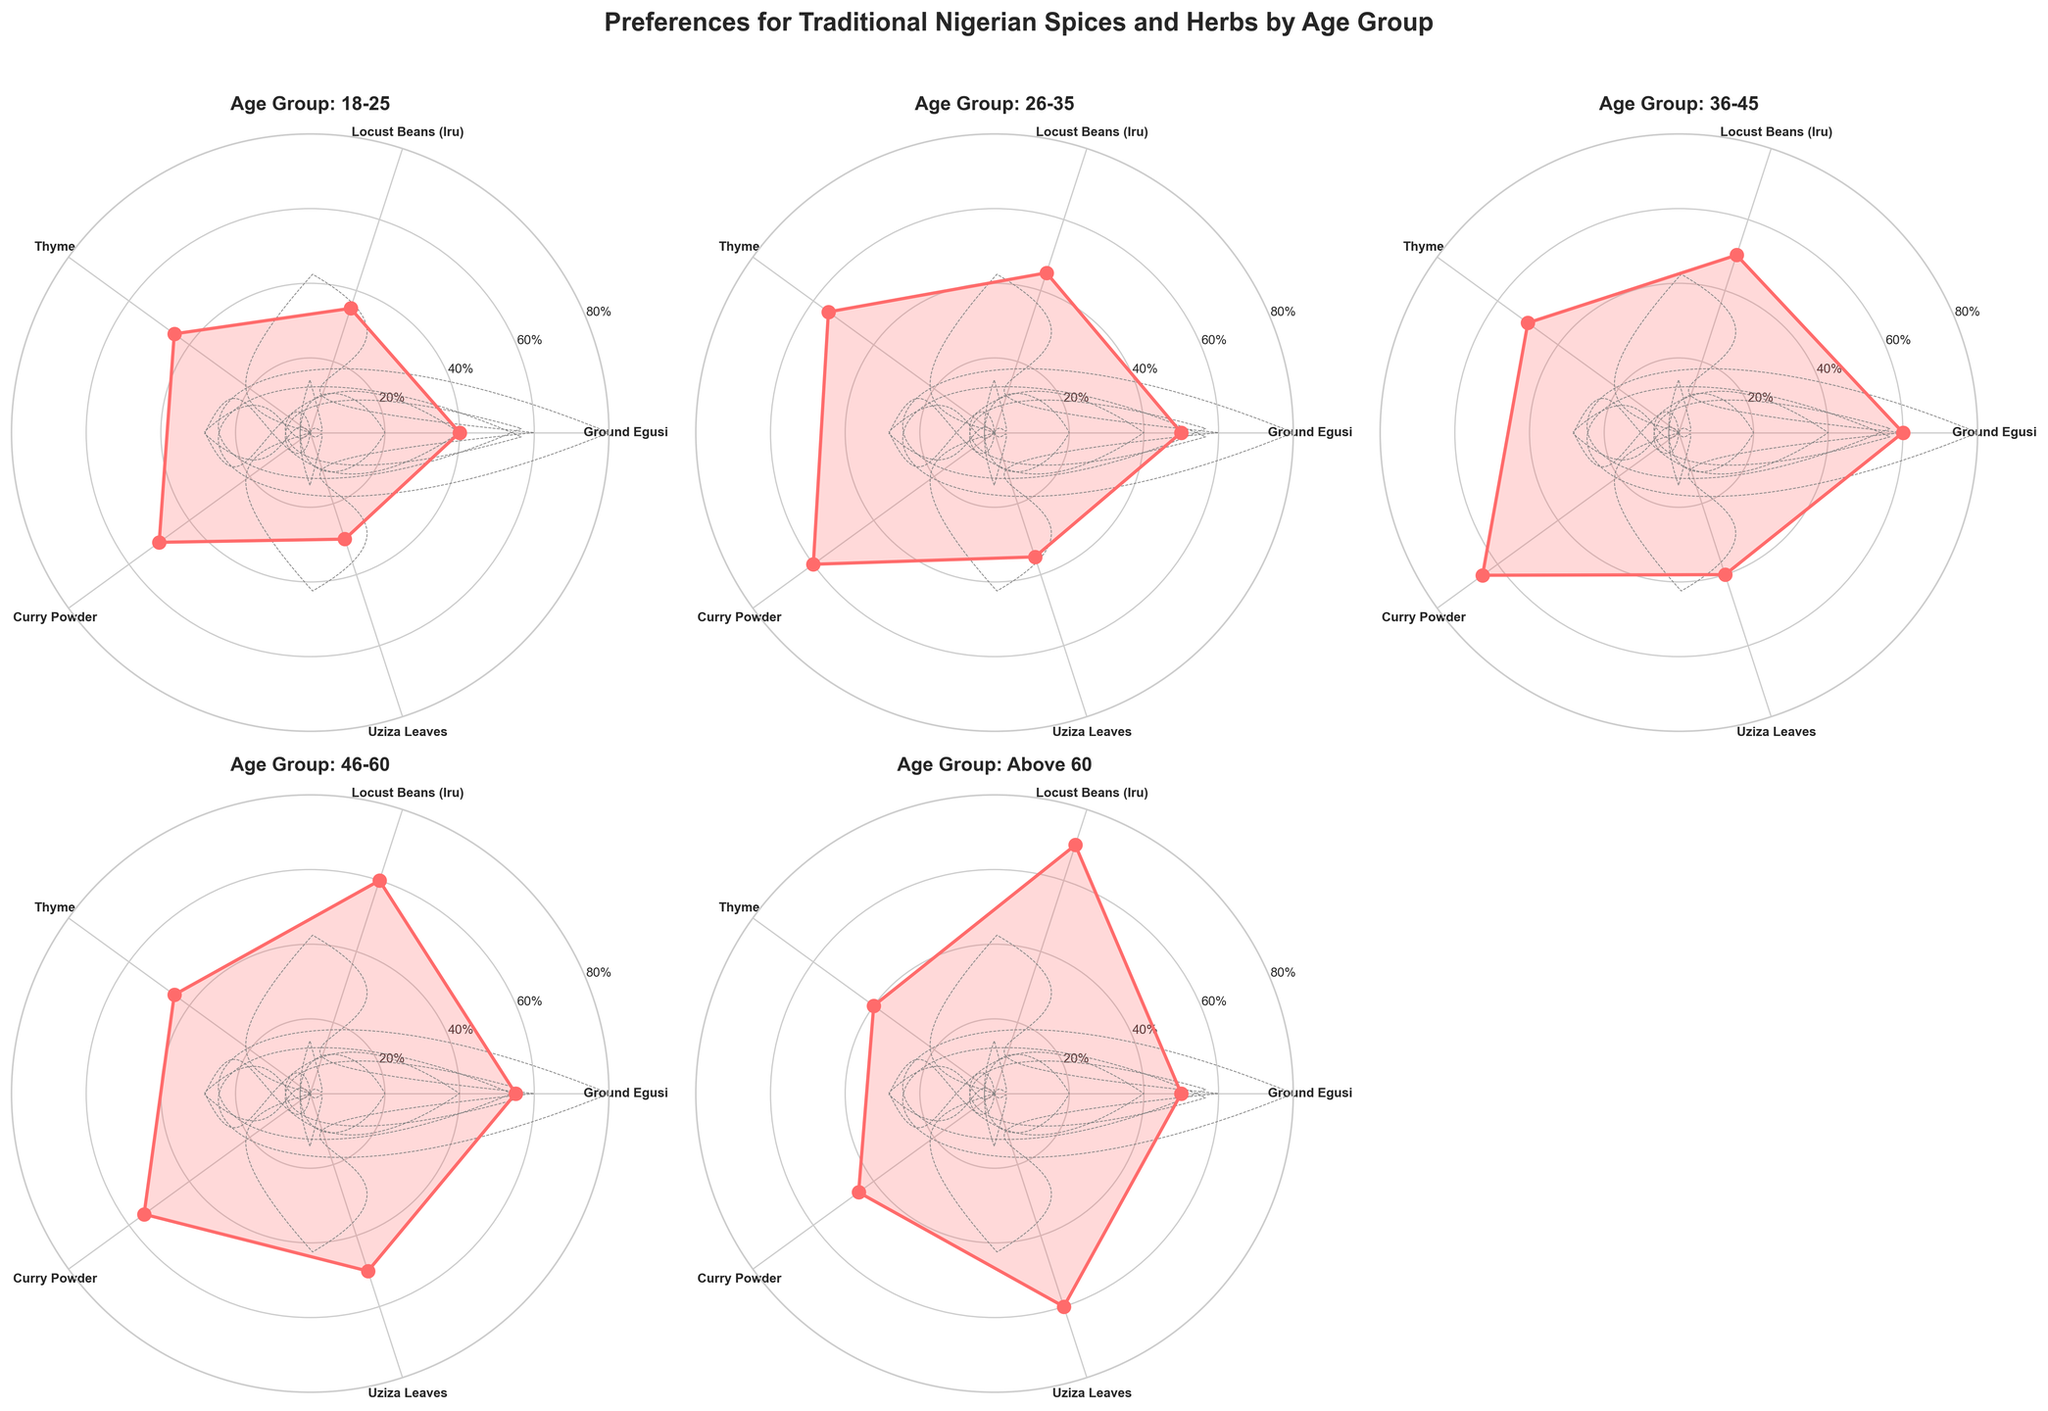How many age groups are represented in the plot? The plot contains individual subplots for each age group. By counting the subplots, we can determine the number of age groups.
Answer: 5 Which spice or herb has the highest preference percentage for the age group 26-35? For the age group 26-35, locate the corresponding subplot and see which spice/herb has the highest value.
Answer: Curry Powder What is the difference in preference percentage for Locust Beans (Iru) between the age groups 18-25 and 26-35? Check the preference percentages for Locust Beans (Iru) in both age groups and subtract the values: 45% (26-35) - 35% (18-25).
Answer: 10% Which age group has the highest preference percentage for Uziza Leaves? Compare the value for Uziza Leaves among all the age groups to see which one is the highest. The highest value is seen in the age group Above 60 with 60%.
Answer: Above 60 Did the preference percentage for Ground Egusi increase or decrease as the age group goes from 18-25 to 36-45? Compare the preference percentages for Ground Egusi in the age groups 18-25 (40%), 26-35 (50%), and 36-45 (60%). The preference percentage is increasing in this age range.
Answer: Increase Which spice or herb shows the least variation in preference percentage across all age groups? Examine the preference percentages for each spice/herb across all age groups. Thyme shows values of 45%, 55%, 50%, 45%, and 40%, showing relatively little variation compared to others. Calculate mean absolute deviation for exact result.
Answer: Thyme What is the average preference percentage for Locust Beans (Iru) across all age groups? Sum the preference values for Locust Beans (Iru) across all age groups: 35 + 45 + 50 + 60 + 70, and then divide by the number of age groups (5). (35+45+50+60+70)/5 = 52%.
Answer: 52% Which age group shows the most balanced preference percentages across all spices and herbs? Find the subplot where the values are more evenly distributed. For example, Age Group 18-25 has percentages 40%, 35%, 45%, 50%, 30%, which shows some balance compared to others.
Answer: 18-25 What is the most common maximum preference percentage among all spice/herb categories? Identify the maximum preference percentage for each spice/herb across all age groups: 60%, 70%, 55%, 65%, 60%, and see which value is more frequent (60% for Ground Egusi and Uziza Leaves).
Answer: 60% Which age group has the lowest preference for Thyme? Compare the preference value of Thyme across all age groups and find the minimum value. The lowest value is for the age group Above 60 with 40%.
Answer: Above 60 